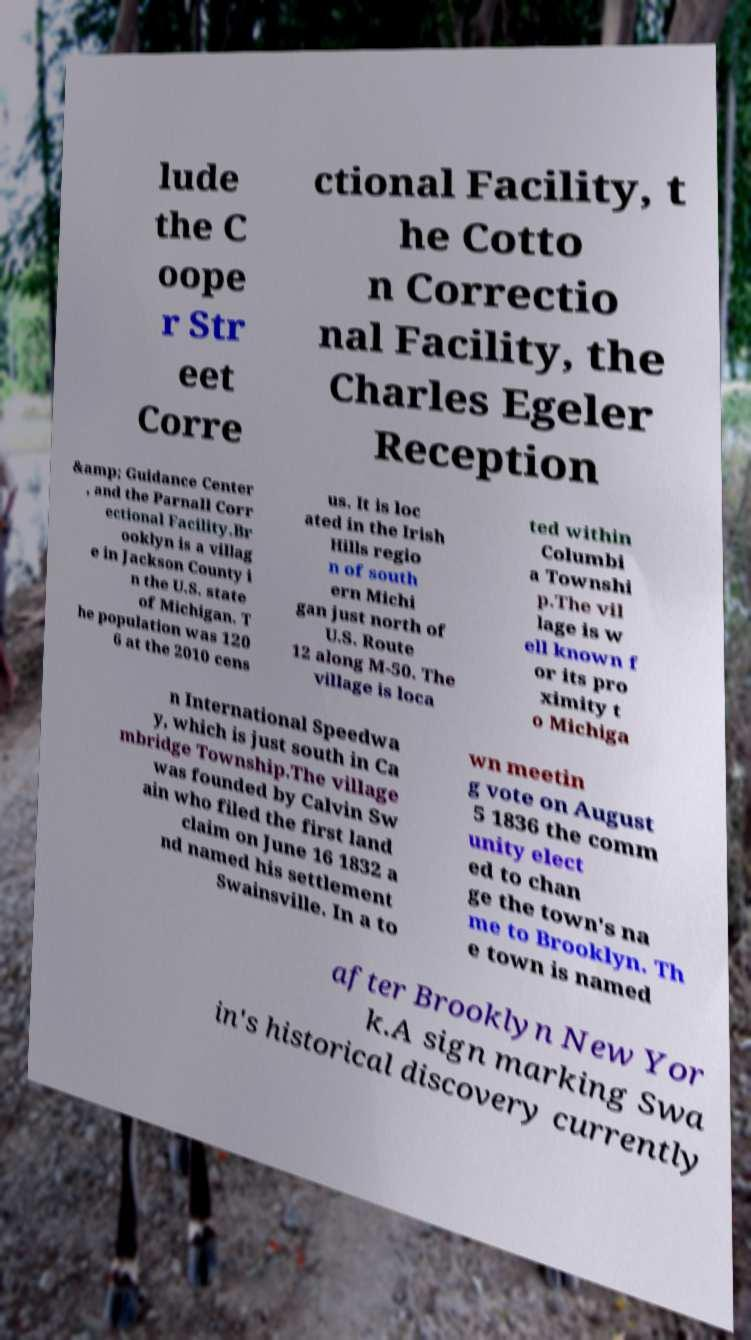Could you assist in decoding the text presented in this image and type it out clearly? lude the C oope r Str eet Corre ctional Facility, t he Cotto n Correctio nal Facility, the Charles Egeler Reception &amp; Guidance Center , and the Parnall Corr ectional Facility.Br ooklyn is a villag e in Jackson County i n the U.S. state of Michigan. T he population was 120 6 at the 2010 cens us. It is loc ated in the Irish Hills regio n of south ern Michi gan just north of U.S. Route 12 along M-50. The village is loca ted within Columbi a Townshi p.The vil lage is w ell known f or its pro ximity t o Michiga n International Speedwa y, which is just south in Ca mbridge Township.The village was founded by Calvin Sw ain who filed the first land claim on June 16 1832 a nd named his settlement Swainsville. In a to wn meetin g vote on August 5 1836 the comm unity elect ed to chan ge the town's na me to Brooklyn. Th e town is named after Brooklyn New Yor k.A sign marking Swa in's historical discovery currently 